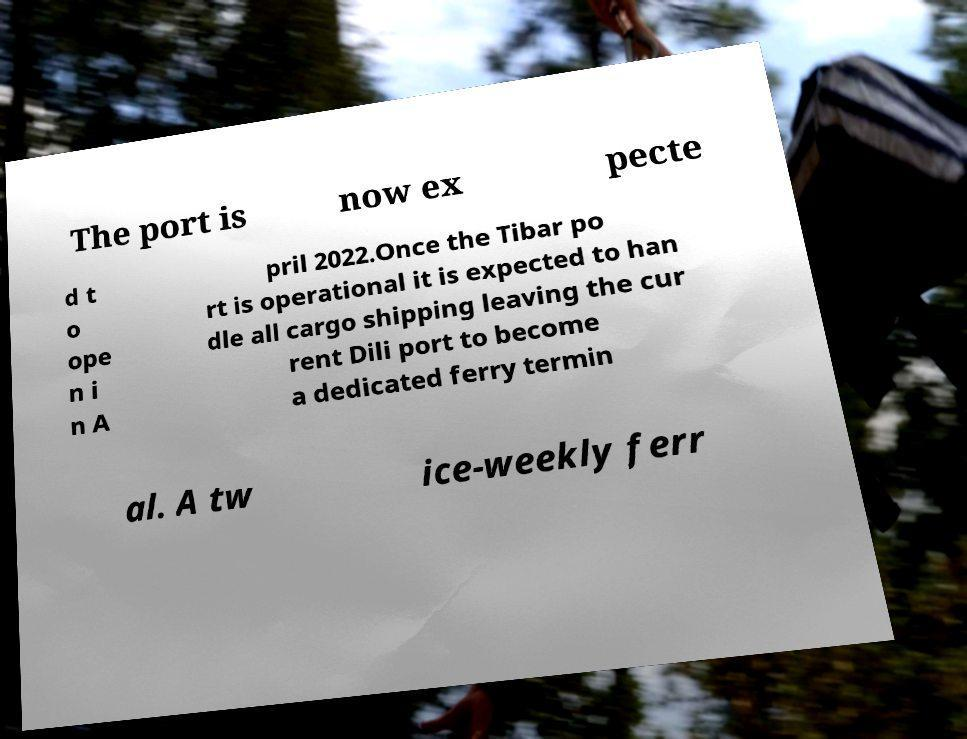Can you accurately transcribe the text from the provided image for me? The port is now ex pecte d t o ope n i n A pril 2022.Once the Tibar po rt is operational it is expected to han dle all cargo shipping leaving the cur rent Dili port to become a dedicated ferry termin al. A tw ice-weekly ferr 